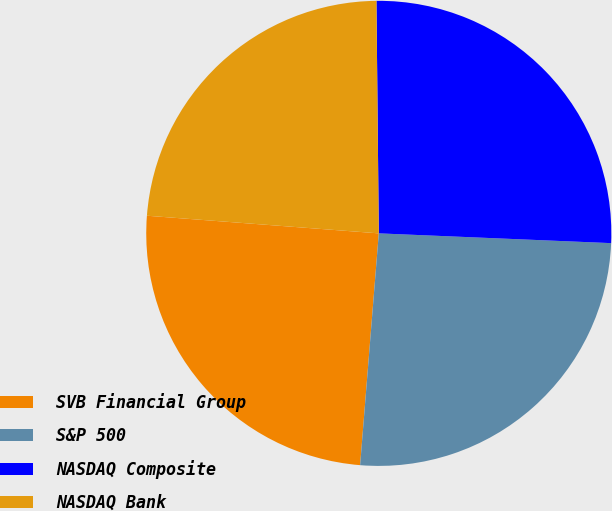Convert chart to OTSL. <chart><loc_0><loc_0><loc_500><loc_500><pie_chart><fcel>SVB Financial Group<fcel>S&P 500<fcel>NASDAQ Composite<fcel>NASDAQ Bank<nl><fcel>24.93%<fcel>25.61%<fcel>25.83%<fcel>23.63%<nl></chart> 